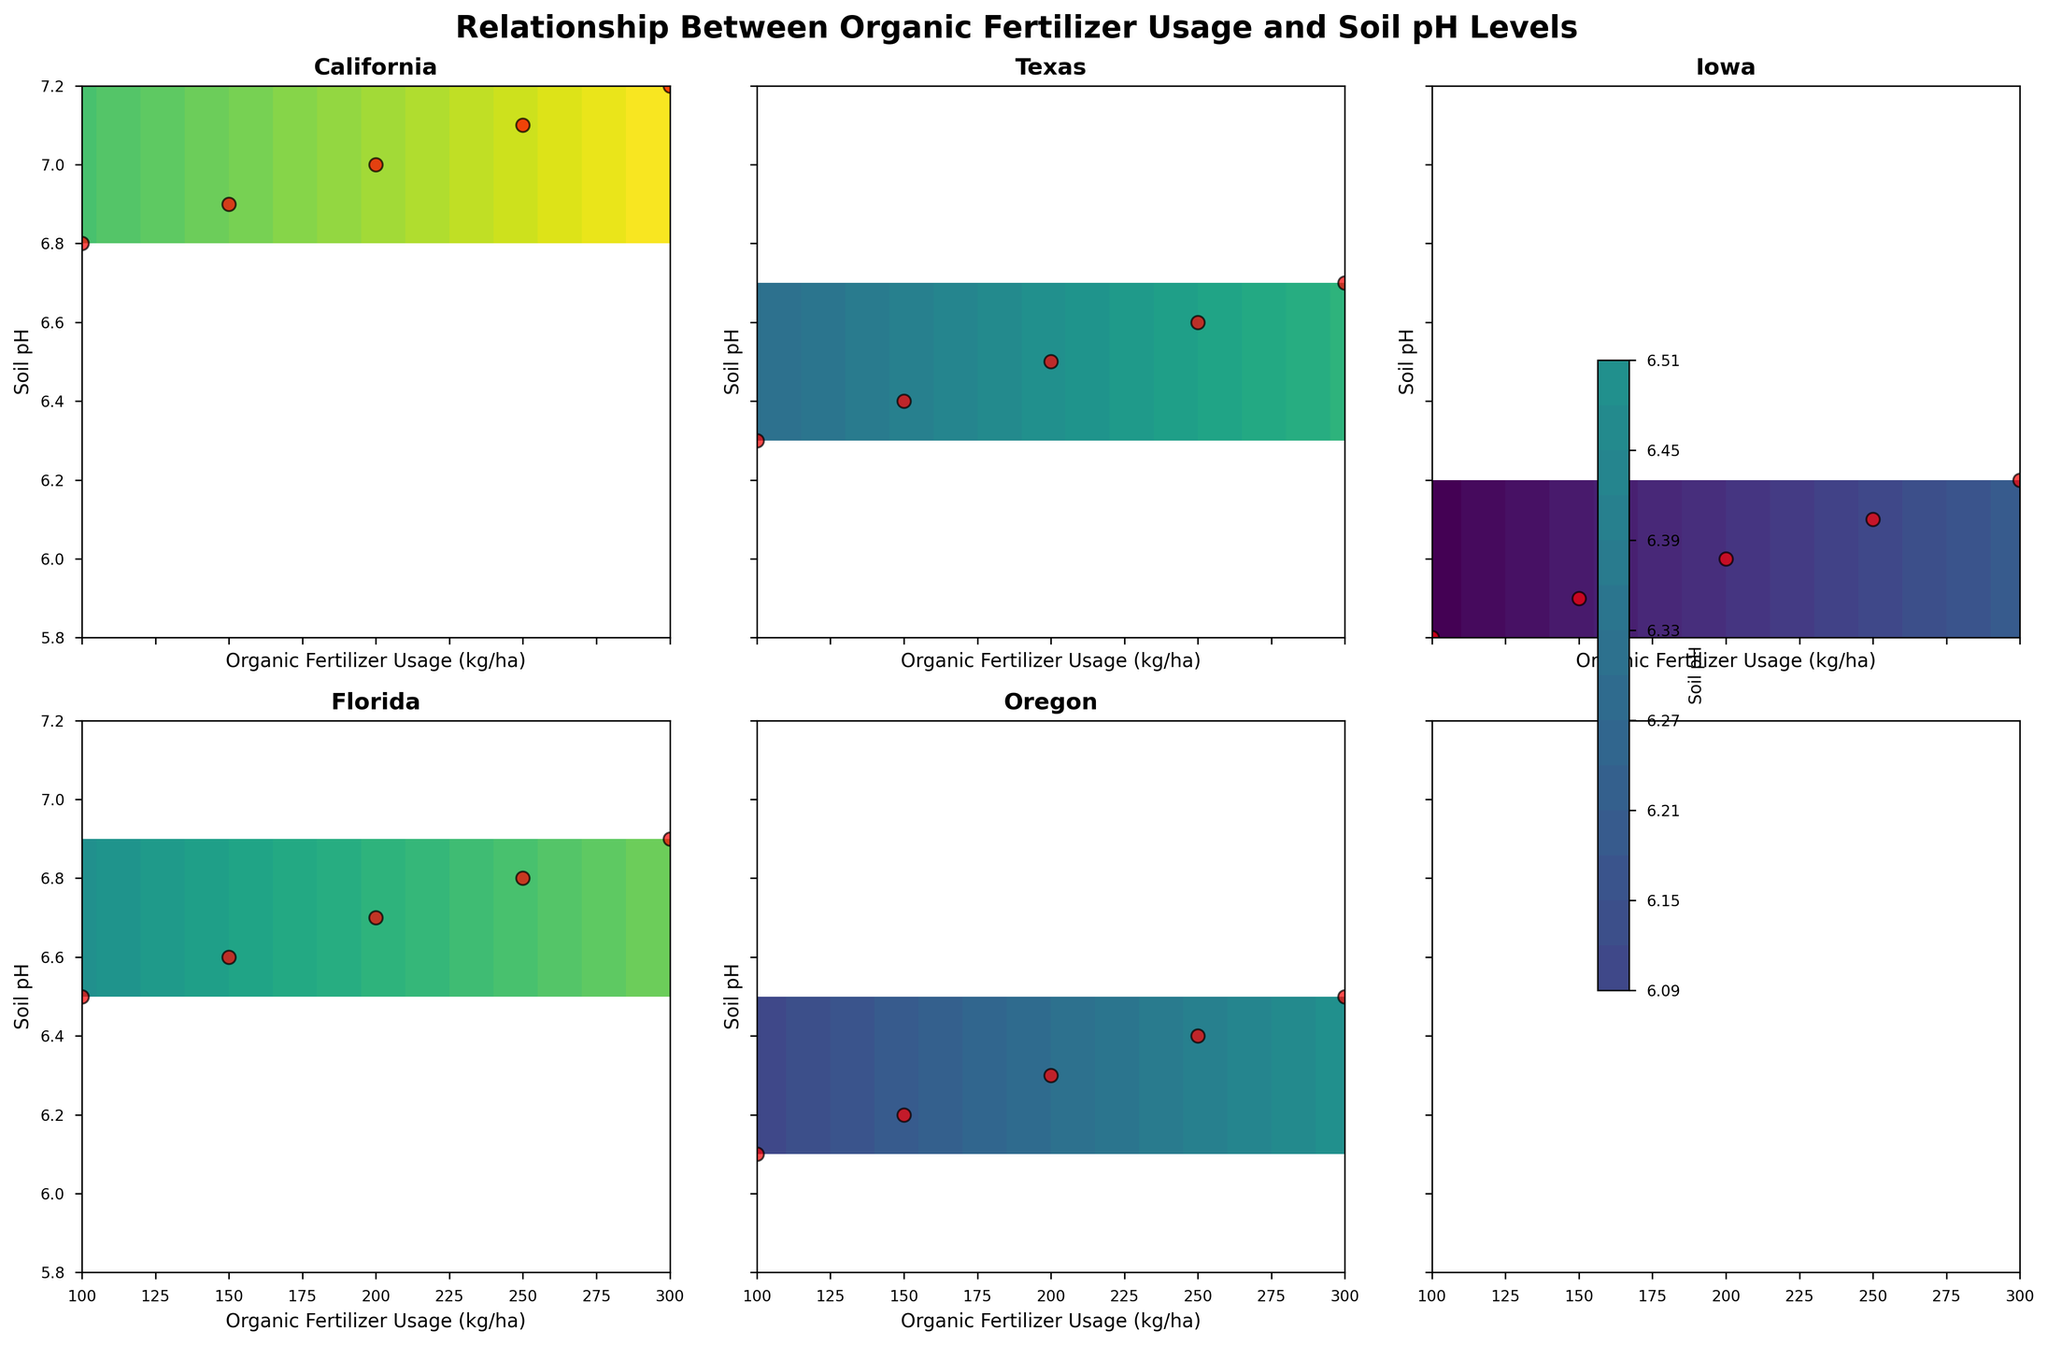What is the title of the figure? The title of the figure is displayed at the top of the plot in bold text.
Answer: Relationship Between Organic Fertilizer Usage and Soil pH Levels What is the range of Organic Fertilizer Usage (kg/ha) in the subplots? The x-axis that displays Organic Fertilizer Usage (kg/ha) spans from the minimum value to the maximum value seen in the data, which ranges from 100 to 300 kg/ha.
Answer: 100 to 300 Which region shows the highest soil pH value and what is that value? By inspecting the y-axis and the highest points in the subplots corresponding to each region, the highest soil pH value is observed in California, reaching 7.2.
Answer: California, 7.2 How many regions are displayed in this figure? The subplots are arranged in a 2x3 grid, but not all slots are filled. Counting the number of titles, there are five regions represented.
Answer: 5 Is there any region where the soil pH remains below 6.0, and if so, which one? By looking at the y-axis of each subplot, only Iowa has values where the soil pH remains below 6.0. This can be seen in the range of Organic Fertilizer Usage values presented.
Answer: Iowa In which region does the soil pH increase the most as Organic Fertilizer Usage increases from 100 kg/ha to 300 kg/ha? By examining the y-axis range within each subplot from the minimum to maximum values of Organic Fertilizer Usage, California shows the largest increase in soil pH from 6.8 to 7.2, making a difference of 0.4.
Answer: California Do all regions show a positive correlation between Organic Fertilizer Usage and Soil pH? Checking the individual subplots, it is evident that each region's soil pH increases as Organic Fertilizer Usage increases, indicating a positive correlation across all regions.
Answer: Yes Which region has the least steep gradient for soil pH change with respect to Organic Fertilizer Usage? By visually comparing the slopes of the contours, Texas shows the least steep gradient, with its soil pH increasing from 6.3 to 6.7 over the interval of Organic Fertilizer Usage from 100 to 300 kg/ha.
Answer: Texas 